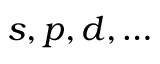Convert formula to latex. <formula><loc_0><loc_0><loc_500><loc_500>s , p , d , \dots</formula> 